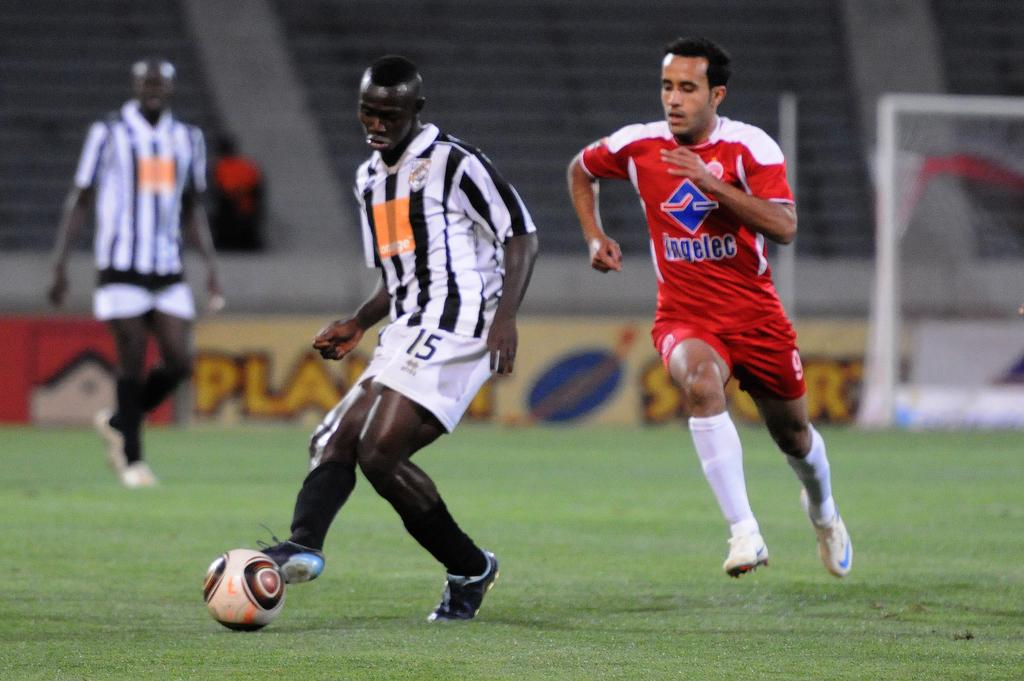How many people are in the image? There are three men in the image. What activity are the men engaged in? The men are playing football. What object is present in the image related to the game? There is a net in the image. Can you see any guitar players in the image? No, there are no guitar players in the image; the men are playing football. Are there any fairies visible in the image? No, there are no fairies present in the image. 